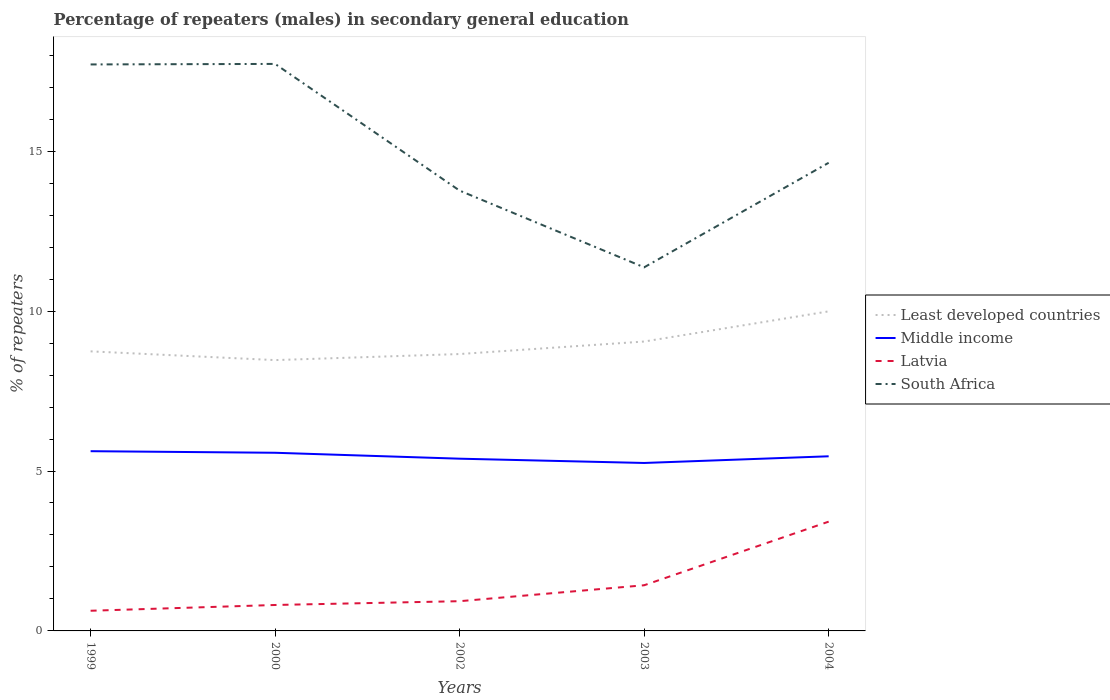How many different coloured lines are there?
Offer a very short reply. 4. Does the line corresponding to South Africa intersect with the line corresponding to Latvia?
Provide a succinct answer. No. Across all years, what is the maximum percentage of male repeaters in Latvia?
Your response must be concise. 0.63. In which year was the percentage of male repeaters in South Africa maximum?
Your answer should be very brief. 2003. What is the total percentage of male repeaters in Middle income in the graph?
Provide a succinct answer. 0.37. What is the difference between the highest and the second highest percentage of male repeaters in Latvia?
Your response must be concise. 2.79. What is the difference between the highest and the lowest percentage of male repeaters in Least developed countries?
Provide a short and direct response. 2. How many lines are there?
Your answer should be compact. 4. Are the values on the major ticks of Y-axis written in scientific E-notation?
Offer a very short reply. No. Does the graph contain grids?
Offer a very short reply. No. Where does the legend appear in the graph?
Your response must be concise. Center right. How many legend labels are there?
Your answer should be compact. 4. How are the legend labels stacked?
Provide a short and direct response. Vertical. What is the title of the graph?
Ensure brevity in your answer.  Percentage of repeaters (males) in secondary general education. What is the label or title of the Y-axis?
Keep it short and to the point. % of repeaters. What is the % of repeaters in Least developed countries in 1999?
Offer a terse response. 8.74. What is the % of repeaters of Middle income in 1999?
Offer a very short reply. 5.62. What is the % of repeaters of Latvia in 1999?
Your response must be concise. 0.63. What is the % of repeaters of South Africa in 1999?
Your answer should be compact. 17.71. What is the % of repeaters in Least developed countries in 2000?
Provide a short and direct response. 8.47. What is the % of repeaters in Middle income in 2000?
Your answer should be compact. 5.57. What is the % of repeaters in Latvia in 2000?
Keep it short and to the point. 0.81. What is the % of repeaters in South Africa in 2000?
Your answer should be very brief. 17.73. What is the % of repeaters of Least developed countries in 2002?
Your answer should be compact. 8.66. What is the % of repeaters in Middle income in 2002?
Provide a short and direct response. 5.39. What is the % of repeaters of Latvia in 2002?
Ensure brevity in your answer.  0.93. What is the % of repeaters in South Africa in 2002?
Provide a short and direct response. 13.77. What is the % of repeaters of Least developed countries in 2003?
Your answer should be compact. 9.05. What is the % of repeaters in Middle income in 2003?
Offer a very short reply. 5.25. What is the % of repeaters in Latvia in 2003?
Your answer should be very brief. 1.43. What is the % of repeaters of South Africa in 2003?
Keep it short and to the point. 11.37. What is the % of repeaters of Least developed countries in 2004?
Your response must be concise. 9.99. What is the % of repeaters in Middle income in 2004?
Offer a terse response. 5.46. What is the % of repeaters in Latvia in 2004?
Make the answer very short. 3.42. What is the % of repeaters in South Africa in 2004?
Ensure brevity in your answer.  14.64. Across all years, what is the maximum % of repeaters in Least developed countries?
Provide a short and direct response. 9.99. Across all years, what is the maximum % of repeaters of Middle income?
Your answer should be very brief. 5.62. Across all years, what is the maximum % of repeaters in Latvia?
Keep it short and to the point. 3.42. Across all years, what is the maximum % of repeaters in South Africa?
Make the answer very short. 17.73. Across all years, what is the minimum % of repeaters in Least developed countries?
Ensure brevity in your answer.  8.47. Across all years, what is the minimum % of repeaters in Middle income?
Offer a terse response. 5.25. Across all years, what is the minimum % of repeaters of Latvia?
Your answer should be very brief. 0.63. Across all years, what is the minimum % of repeaters of South Africa?
Your response must be concise. 11.37. What is the total % of repeaters in Least developed countries in the graph?
Your answer should be very brief. 44.91. What is the total % of repeaters of Middle income in the graph?
Your response must be concise. 27.29. What is the total % of repeaters in Latvia in the graph?
Provide a short and direct response. 7.22. What is the total % of repeaters in South Africa in the graph?
Your answer should be compact. 75.21. What is the difference between the % of repeaters of Least developed countries in 1999 and that in 2000?
Offer a terse response. 0.27. What is the difference between the % of repeaters in Middle income in 1999 and that in 2000?
Your response must be concise. 0.05. What is the difference between the % of repeaters in Latvia in 1999 and that in 2000?
Provide a succinct answer. -0.18. What is the difference between the % of repeaters of South Africa in 1999 and that in 2000?
Ensure brevity in your answer.  -0.02. What is the difference between the % of repeaters of Least developed countries in 1999 and that in 2002?
Ensure brevity in your answer.  0.08. What is the difference between the % of repeaters in Middle income in 1999 and that in 2002?
Offer a terse response. 0.23. What is the difference between the % of repeaters in Latvia in 1999 and that in 2002?
Your answer should be very brief. -0.3. What is the difference between the % of repeaters of South Africa in 1999 and that in 2002?
Provide a short and direct response. 3.95. What is the difference between the % of repeaters of Least developed countries in 1999 and that in 2003?
Provide a succinct answer. -0.31. What is the difference between the % of repeaters in Middle income in 1999 and that in 2003?
Provide a succinct answer. 0.37. What is the difference between the % of repeaters of Latvia in 1999 and that in 2003?
Your answer should be very brief. -0.8. What is the difference between the % of repeaters of South Africa in 1999 and that in 2003?
Your response must be concise. 6.34. What is the difference between the % of repeaters in Least developed countries in 1999 and that in 2004?
Your response must be concise. -1.25. What is the difference between the % of repeaters in Middle income in 1999 and that in 2004?
Ensure brevity in your answer.  0.16. What is the difference between the % of repeaters of Latvia in 1999 and that in 2004?
Your answer should be very brief. -2.79. What is the difference between the % of repeaters in South Africa in 1999 and that in 2004?
Ensure brevity in your answer.  3.08. What is the difference between the % of repeaters of Least developed countries in 2000 and that in 2002?
Give a very brief answer. -0.19. What is the difference between the % of repeaters in Middle income in 2000 and that in 2002?
Offer a terse response. 0.19. What is the difference between the % of repeaters of Latvia in 2000 and that in 2002?
Give a very brief answer. -0.12. What is the difference between the % of repeaters of South Africa in 2000 and that in 2002?
Your answer should be very brief. 3.96. What is the difference between the % of repeaters in Least developed countries in 2000 and that in 2003?
Your answer should be very brief. -0.58. What is the difference between the % of repeaters of Middle income in 2000 and that in 2003?
Give a very brief answer. 0.32. What is the difference between the % of repeaters in Latvia in 2000 and that in 2003?
Keep it short and to the point. -0.62. What is the difference between the % of repeaters of South Africa in 2000 and that in 2003?
Provide a succinct answer. 6.36. What is the difference between the % of repeaters in Least developed countries in 2000 and that in 2004?
Give a very brief answer. -1.52. What is the difference between the % of repeaters in Middle income in 2000 and that in 2004?
Make the answer very short. 0.11. What is the difference between the % of repeaters of Latvia in 2000 and that in 2004?
Your answer should be compact. -2.61. What is the difference between the % of repeaters in South Africa in 2000 and that in 2004?
Offer a terse response. 3.09. What is the difference between the % of repeaters in Least developed countries in 2002 and that in 2003?
Ensure brevity in your answer.  -0.39. What is the difference between the % of repeaters of Middle income in 2002 and that in 2003?
Make the answer very short. 0.13. What is the difference between the % of repeaters of Latvia in 2002 and that in 2003?
Provide a succinct answer. -0.5. What is the difference between the % of repeaters in South Africa in 2002 and that in 2003?
Offer a terse response. 2.4. What is the difference between the % of repeaters of Least developed countries in 2002 and that in 2004?
Your response must be concise. -1.33. What is the difference between the % of repeaters of Middle income in 2002 and that in 2004?
Provide a short and direct response. -0.07. What is the difference between the % of repeaters in Latvia in 2002 and that in 2004?
Provide a short and direct response. -2.49. What is the difference between the % of repeaters in South Africa in 2002 and that in 2004?
Your answer should be very brief. -0.87. What is the difference between the % of repeaters of Least developed countries in 2003 and that in 2004?
Make the answer very short. -0.94. What is the difference between the % of repeaters of Middle income in 2003 and that in 2004?
Your answer should be very brief. -0.21. What is the difference between the % of repeaters in Latvia in 2003 and that in 2004?
Your answer should be very brief. -1.99. What is the difference between the % of repeaters of South Africa in 2003 and that in 2004?
Give a very brief answer. -3.27. What is the difference between the % of repeaters in Least developed countries in 1999 and the % of repeaters in Middle income in 2000?
Provide a succinct answer. 3.17. What is the difference between the % of repeaters in Least developed countries in 1999 and the % of repeaters in Latvia in 2000?
Make the answer very short. 7.93. What is the difference between the % of repeaters in Least developed countries in 1999 and the % of repeaters in South Africa in 2000?
Ensure brevity in your answer.  -8.99. What is the difference between the % of repeaters of Middle income in 1999 and the % of repeaters of Latvia in 2000?
Your answer should be compact. 4.81. What is the difference between the % of repeaters of Middle income in 1999 and the % of repeaters of South Africa in 2000?
Your answer should be very brief. -12.11. What is the difference between the % of repeaters of Latvia in 1999 and the % of repeaters of South Africa in 2000?
Provide a succinct answer. -17.1. What is the difference between the % of repeaters in Least developed countries in 1999 and the % of repeaters in Middle income in 2002?
Keep it short and to the point. 3.36. What is the difference between the % of repeaters of Least developed countries in 1999 and the % of repeaters of Latvia in 2002?
Give a very brief answer. 7.81. What is the difference between the % of repeaters of Least developed countries in 1999 and the % of repeaters of South Africa in 2002?
Keep it short and to the point. -5.03. What is the difference between the % of repeaters of Middle income in 1999 and the % of repeaters of Latvia in 2002?
Keep it short and to the point. 4.69. What is the difference between the % of repeaters in Middle income in 1999 and the % of repeaters in South Africa in 2002?
Offer a very short reply. -8.15. What is the difference between the % of repeaters of Latvia in 1999 and the % of repeaters of South Africa in 2002?
Your answer should be compact. -13.14. What is the difference between the % of repeaters in Least developed countries in 1999 and the % of repeaters in Middle income in 2003?
Keep it short and to the point. 3.49. What is the difference between the % of repeaters of Least developed countries in 1999 and the % of repeaters of Latvia in 2003?
Your response must be concise. 7.31. What is the difference between the % of repeaters in Least developed countries in 1999 and the % of repeaters in South Africa in 2003?
Provide a succinct answer. -2.63. What is the difference between the % of repeaters in Middle income in 1999 and the % of repeaters in Latvia in 2003?
Keep it short and to the point. 4.19. What is the difference between the % of repeaters in Middle income in 1999 and the % of repeaters in South Africa in 2003?
Provide a succinct answer. -5.75. What is the difference between the % of repeaters of Latvia in 1999 and the % of repeaters of South Africa in 2003?
Provide a short and direct response. -10.74. What is the difference between the % of repeaters of Least developed countries in 1999 and the % of repeaters of Middle income in 2004?
Your response must be concise. 3.28. What is the difference between the % of repeaters of Least developed countries in 1999 and the % of repeaters of Latvia in 2004?
Provide a short and direct response. 5.32. What is the difference between the % of repeaters of Least developed countries in 1999 and the % of repeaters of South Africa in 2004?
Offer a very short reply. -5.9. What is the difference between the % of repeaters of Middle income in 1999 and the % of repeaters of Latvia in 2004?
Offer a very short reply. 2.2. What is the difference between the % of repeaters in Middle income in 1999 and the % of repeaters in South Africa in 2004?
Your response must be concise. -9.02. What is the difference between the % of repeaters in Latvia in 1999 and the % of repeaters in South Africa in 2004?
Ensure brevity in your answer.  -14.01. What is the difference between the % of repeaters of Least developed countries in 2000 and the % of repeaters of Middle income in 2002?
Your answer should be compact. 3.08. What is the difference between the % of repeaters of Least developed countries in 2000 and the % of repeaters of Latvia in 2002?
Your answer should be very brief. 7.54. What is the difference between the % of repeaters in Least developed countries in 2000 and the % of repeaters in South Africa in 2002?
Your response must be concise. -5.3. What is the difference between the % of repeaters in Middle income in 2000 and the % of repeaters in Latvia in 2002?
Keep it short and to the point. 4.64. What is the difference between the % of repeaters in Middle income in 2000 and the % of repeaters in South Africa in 2002?
Provide a short and direct response. -8.2. What is the difference between the % of repeaters of Latvia in 2000 and the % of repeaters of South Africa in 2002?
Your answer should be very brief. -12.96. What is the difference between the % of repeaters of Least developed countries in 2000 and the % of repeaters of Middle income in 2003?
Offer a terse response. 3.22. What is the difference between the % of repeaters of Least developed countries in 2000 and the % of repeaters of Latvia in 2003?
Your answer should be compact. 7.04. What is the difference between the % of repeaters of Least developed countries in 2000 and the % of repeaters of South Africa in 2003?
Make the answer very short. -2.9. What is the difference between the % of repeaters of Middle income in 2000 and the % of repeaters of Latvia in 2003?
Provide a short and direct response. 4.14. What is the difference between the % of repeaters in Middle income in 2000 and the % of repeaters in South Africa in 2003?
Keep it short and to the point. -5.8. What is the difference between the % of repeaters of Latvia in 2000 and the % of repeaters of South Africa in 2003?
Provide a short and direct response. -10.56. What is the difference between the % of repeaters in Least developed countries in 2000 and the % of repeaters in Middle income in 2004?
Your response must be concise. 3.01. What is the difference between the % of repeaters in Least developed countries in 2000 and the % of repeaters in Latvia in 2004?
Offer a terse response. 5.05. What is the difference between the % of repeaters of Least developed countries in 2000 and the % of repeaters of South Africa in 2004?
Keep it short and to the point. -6.17. What is the difference between the % of repeaters of Middle income in 2000 and the % of repeaters of Latvia in 2004?
Make the answer very short. 2.15. What is the difference between the % of repeaters in Middle income in 2000 and the % of repeaters in South Africa in 2004?
Ensure brevity in your answer.  -9.07. What is the difference between the % of repeaters of Latvia in 2000 and the % of repeaters of South Africa in 2004?
Your answer should be very brief. -13.83. What is the difference between the % of repeaters in Least developed countries in 2002 and the % of repeaters in Middle income in 2003?
Make the answer very short. 3.41. What is the difference between the % of repeaters in Least developed countries in 2002 and the % of repeaters in Latvia in 2003?
Your response must be concise. 7.23. What is the difference between the % of repeaters of Least developed countries in 2002 and the % of repeaters of South Africa in 2003?
Provide a succinct answer. -2.71. What is the difference between the % of repeaters in Middle income in 2002 and the % of repeaters in Latvia in 2003?
Make the answer very short. 3.96. What is the difference between the % of repeaters in Middle income in 2002 and the % of repeaters in South Africa in 2003?
Provide a short and direct response. -5.98. What is the difference between the % of repeaters in Latvia in 2002 and the % of repeaters in South Africa in 2003?
Make the answer very short. -10.44. What is the difference between the % of repeaters of Least developed countries in 2002 and the % of repeaters of Middle income in 2004?
Offer a terse response. 3.2. What is the difference between the % of repeaters of Least developed countries in 2002 and the % of repeaters of Latvia in 2004?
Your answer should be very brief. 5.24. What is the difference between the % of repeaters in Least developed countries in 2002 and the % of repeaters in South Africa in 2004?
Make the answer very short. -5.98. What is the difference between the % of repeaters in Middle income in 2002 and the % of repeaters in Latvia in 2004?
Ensure brevity in your answer.  1.97. What is the difference between the % of repeaters of Middle income in 2002 and the % of repeaters of South Africa in 2004?
Provide a short and direct response. -9.25. What is the difference between the % of repeaters in Latvia in 2002 and the % of repeaters in South Africa in 2004?
Keep it short and to the point. -13.71. What is the difference between the % of repeaters in Least developed countries in 2003 and the % of repeaters in Middle income in 2004?
Make the answer very short. 3.59. What is the difference between the % of repeaters of Least developed countries in 2003 and the % of repeaters of Latvia in 2004?
Ensure brevity in your answer.  5.63. What is the difference between the % of repeaters in Least developed countries in 2003 and the % of repeaters in South Africa in 2004?
Offer a very short reply. -5.59. What is the difference between the % of repeaters of Middle income in 2003 and the % of repeaters of Latvia in 2004?
Ensure brevity in your answer.  1.83. What is the difference between the % of repeaters in Middle income in 2003 and the % of repeaters in South Africa in 2004?
Offer a very short reply. -9.39. What is the difference between the % of repeaters in Latvia in 2003 and the % of repeaters in South Africa in 2004?
Your answer should be very brief. -13.21. What is the average % of repeaters of Least developed countries per year?
Your answer should be very brief. 8.98. What is the average % of repeaters in Middle income per year?
Provide a short and direct response. 5.46. What is the average % of repeaters in Latvia per year?
Ensure brevity in your answer.  1.44. What is the average % of repeaters in South Africa per year?
Offer a terse response. 15.04. In the year 1999, what is the difference between the % of repeaters of Least developed countries and % of repeaters of Middle income?
Give a very brief answer. 3.12. In the year 1999, what is the difference between the % of repeaters of Least developed countries and % of repeaters of Latvia?
Offer a terse response. 8.11. In the year 1999, what is the difference between the % of repeaters of Least developed countries and % of repeaters of South Africa?
Your answer should be compact. -8.97. In the year 1999, what is the difference between the % of repeaters of Middle income and % of repeaters of Latvia?
Provide a succinct answer. 4.99. In the year 1999, what is the difference between the % of repeaters in Middle income and % of repeaters in South Africa?
Keep it short and to the point. -12.09. In the year 1999, what is the difference between the % of repeaters in Latvia and % of repeaters in South Africa?
Give a very brief answer. -17.08. In the year 2000, what is the difference between the % of repeaters of Least developed countries and % of repeaters of Middle income?
Make the answer very short. 2.9. In the year 2000, what is the difference between the % of repeaters in Least developed countries and % of repeaters in Latvia?
Your answer should be compact. 7.66. In the year 2000, what is the difference between the % of repeaters in Least developed countries and % of repeaters in South Africa?
Offer a very short reply. -9.26. In the year 2000, what is the difference between the % of repeaters in Middle income and % of repeaters in Latvia?
Your answer should be compact. 4.76. In the year 2000, what is the difference between the % of repeaters of Middle income and % of repeaters of South Africa?
Provide a succinct answer. -12.16. In the year 2000, what is the difference between the % of repeaters of Latvia and % of repeaters of South Africa?
Your answer should be very brief. -16.92. In the year 2002, what is the difference between the % of repeaters in Least developed countries and % of repeaters in Middle income?
Ensure brevity in your answer.  3.27. In the year 2002, what is the difference between the % of repeaters in Least developed countries and % of repeaters in Latvia?
Provide a short and direct response. 7.73. In the year 2002, what is the difference between the % of repeaters in Least developed countries and % of repeaters in South Africa?
Offer a terse response. -5.11. In the year 2002, what is the difference between the % of repeaters of Middle income and % of repeaters of Latvia?
Your answer should be very brief. 4.46. In the year 2002, what is the difference between the % of repeaters of Middle income and % of repeaters of South Africa?
Provide a short and direct response. -8.38. In the year 2002, what is the difference between the % of repeaters in Latvia and % of repeaters in South Africa?
Provide a short and direct response. -12.84. In the year 2003, what is the difference between the % of repeaters of Least developed countries and % of repeaters of Middle income?
Ensure brevity in your answer.  3.8. In the year 2003, what is the difference between the % of repeaters in Least developed countries and % of repeaters in Latvia?
Your answer should be compact. 7.62. In the year 2003, what is the difference between the % of repeaters of Least developed countries and % of repeaters of South Africa?
Your answer should be compact. -2.32. In the year 2003, what is the difference between the % of repeaters in Middle income and % of repeaters in Latvia?
Your response must be concise. 3.82. In the year 2003, what is the difference between the % of repeaters of Middle income and % of repeaters of South Africa?
Provide a short and direct response. -6.12. In the year 2003, what is the difference between the % of repeaters in Latvia and % of repeaters in South Africa?
Your answer should be compact. -9.94. In the year 2004, what is the difference between the % of repeaters of Least developed countries and % of repeaters of Middle income?
Offer a very short reply. 4.53. In the year 2004, what is the difference between the % of repeaters in Least developed countries and % of repeaters in Latvia?
Ensure brevity in your answer.  6.58. In the year 2004, what is the difference between the % of repeaters in Least developed countries and % of repeaters in South Africa?
Your answer should be compact. -4.65. In the year 2004, what is the difference between the % of repeaters of Middle income and % of repeaters of Latvia?
Provide a short and direct response. 2.04. In the year 2004, what is the difference between the % of repeaters of Middle income and % of repeaters of South Africa?
Offer a very short reply. -9.18. In the year 2004, what is the difference between the % of repeaters in Latvia and % of repeaters in South Africa?
Offer a very short reply. -11.22. What is the ratio of the % of repeaters in Least developed countries in 1999 to that in 2000?
Provide a succinct answer. 1.03. What is the ratio of the % of repeaters of Middle income in 1999 to that in 2000?
Give a very brief answer. 1.01. What is the ratio of the % of repeaters in Latvia in 1999 to that in 2000?
Offer a terse response. 0.78. What is the ratio of the % of repeaters in South Africa in 1999 to that in 2000?
Your answer should be compact. 1. What is the ratio of the % of repeaters in Least developed countries in 1999 to that in 2002?
Ensure brevity in your answer.  1.01. What is the ratio of the % of repeaters in Middle income in 1999 to that in 2002?
Give a very brief answer. 1.04. What is the ratio of the % of repeaters in Latvia in 1999 to that in 2002?
Offer a very short reply. 0.68. What is the ratio of the % of repeaters of South Africa in 1999 to that in 2002?
Give a very brief answer. 1.29. What is the ratio of the % of repeaters in Least developed countries in 1999 to that in 2003?
Provide a short and direct response. 0.97. What is the ratio of the % of repeaters in Middle income in 1999 to that in 2003?
Offer a terse response. 1.07. What is the ratio of the % of repeaters of Latvia in 1999 to that in 2003?
Offer a very short reply. 0.44. What is the ratio of the % of repeaters in South Africa in 1999 to that in 2003?
Offer a terse response. 1.56. What is the ratio of the % of repeaters of Least developed countries in 1999 to that in 2004?
Offer a very short reply. 0.87. What is the ratio of the % of repeaters of Middle income in 1999 to that in 2004?
Make the answer very short. 1.03. What is the ratio of the % of repeaters in Latvia in 1999 to that in 2004?
Your response must be concise. 0.18. What is the ratio of the % of repeaters in South Africa in 1999 to that in 2004?
Ensure brevity in your answer.  1.21. What is the ratio of the % of repeaters of Least developed countries in 2000 to that in 2002?
Keep it short and to the point. 0.98. What is the ratio of the % of repeaters in Middle income in 2000 to that in 2002?
Offer a very short reply. 1.03. What is the ratio of the % of repeaters in Latvia in 2000 to that in 2002?
Ensure brevity in your answer.  0.87. What is the ratio of the % of repeaters of South Africa in 2000 to that in 2002?
Your answer should be compact. 1.29. What is the ratio of the % of repeaters of Least developed countries in 2000 to that in 2003?
Provide a short and direct response. 0.94. What is the ratio of the % of repeaters of Middle income in 2000 to that in 2003?
Keep it short and to the point. 1.06. What is the ratio of the % of repeaters in Latvia in 2000 to that in 2003?
Your answer should be compact. 0.57. What is the ratio of the % of repeaters in South Africa in 2000 to that in 2003?
Your answer should be very brief. 1.56. What is the ratio of the % of repeaters in Least developed countries in 2000 to that in 2004?
Offer a very short reply. 0.85. What is the ratio of the % of repeaters of Middle income in 2000 to that in 2004?
Provide a short and direct response. 1.02. What is the ratio of the % of repeaters of Latvia in 2000 to that in 2004?
Make the answer very short. 0.24. What is the ratio of the % of repeaters in South Africa in 2000 to that in 2004?
Provide a succinct answer. 1.21. What is the ratio of the % of repeaters of Least developed countries in 2002 to that in 2003?
Provide a succinct answer. 0.96. What is the ratio of the % of repeaters of Middle income in 2002 to that in 2003?
Offer a very short reply. 1.03. What is the ratio of the % of repeaters of Latvia in 2002 to that in 2003?
Ensure brevity in your answer.  0.65. What is the ratio of the % of repeaters in South Africa in 2002 to that in 2003?
Make the answer very short. 1.21. What is the ratio of the % of repeaters of Least developed countries in 2002 to that in 2004?
Your answer should be compact. 0.87. What is the ratio of the % of repeaters of Middle income in 2002 to that in 2004?
Your response must be concise. 0.99. What is the ratio of the % of repeaters in Latvia in 2002 to that in 2004?
Your response must be concise. 0.27. What is the ratio of the % of repeaters of South Africa in 2002 to that in 2004?
Give a very brief answer. 0.94. What is the ratio of the % of repeaters of Least developed countries in 2003 to that in 2004?
Provide a short and direct response. 0.91. What is the ratio of the % of repeaters in Middle income in 2003 to that in 2004?
Offer a terse response. 0.96. What is the ratio of the % of repeaters of Latvia in 2003 to that in 2004?
Offer a terse response. 0.42. What is the ratio of the % of repeaters in South Africa in 2003 to that in 2004?
Your answer should be very brief. 0.78. What is the difference between the highest and the second highest % of repeaters of Least developed countries?
Keep it short and to the point. 0.94. What is the difference between the highest and the second highest % of repeaters of Middle income?
Offer a very short reply. 0.05. What is the difference between the highest and the second highest % of repeaters in Latvia?
Ensure brevity in your answer.  1.99. What is the difference between the highest and the second highest % of repeaters in South Africa?
Provide a succinct answer. 0.02. What is the difference between the highest and the lowest % of repeaters in Least developed countries?
Your answer should be compact. 1.52. What is the difference between the highest and the lowest % of repeaters of Middle income?
Your answer should be very brief. 0.37. What is the difference between the highest and the lowest % of repeaters in Latvia?
Keep it short and to the point. 2.79. What is the difference between the highest and the lowest % of repeaters in South Africa?
Provide a succinct answer. 6.36. 